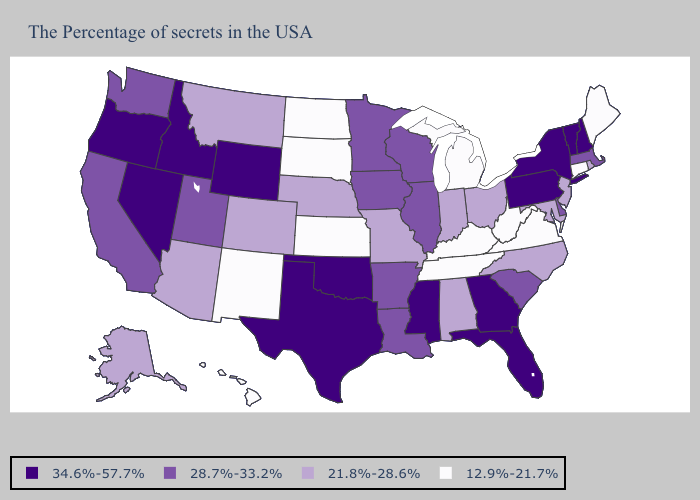What is the value of Kansas?
Answer briefly. 12.9%-21.7%. Does Connecticut have the highest value in the Northeast?
Give a very brief answer. No. Name the states that have a value in the range 12.9%-21.7%?
Be succinct. Maine, Connecticut, Virginia, West Virginia, Michigan, Kentucky, Tennessee, Kansas, South Dakota, North Dakota, New Mexico, Hawaii. Does the first symbol in the legend represent the smallest category?
Keep it brief. No. Does Oklahoma have the highest value in the USA?
Answer briefly. Yes. Among the states that border New York , does Connecticut have the highest value?
Write a very short answer. No. Does South Carolina have the lowest value in the South?
Quick response, please. No. Name the states that have a value in the range 21.8%-28.6%?
Write a very short answer. Rhode Island, New Jersey, Maryland, North Carolina, Ohio, Indiana, Alabama, Missouri, Nebraska, Colorado, Montana, Arizona, Alaska. Name the states that have a value in the range 21.8%-28.6%?
Short answer required. Rhode Island, New Jersey, Maryland, North Carolina, Ohio, Indiana, Alabama, Missouri, Nebraska, Colorado, Montana, Arizona, Alaska. What is the value of Oregon?
Write a very short answer. 34.6%-57.7%. What is the value of Vermont?
Keep it brief. 34.6%-57.7%. Among the states that border Rhode Island , does Connecticut have the lowest value?
Write a very short answer. Yes. What is the highest value in states that border Nebraska?
Answer briefly. 34.6%-57.7%. Does Ohio have the highest value in the MidWest?
Short answer required. No. Name the states that have a value in the range 12.9%-21.7%?
Quick response, please. Maine, Connecticut, Virginia, West Virginia, Michigan, Kentucky, Tennessee, Kansas, South Dakota, North Dakota, New Mexico, Hawaii. 